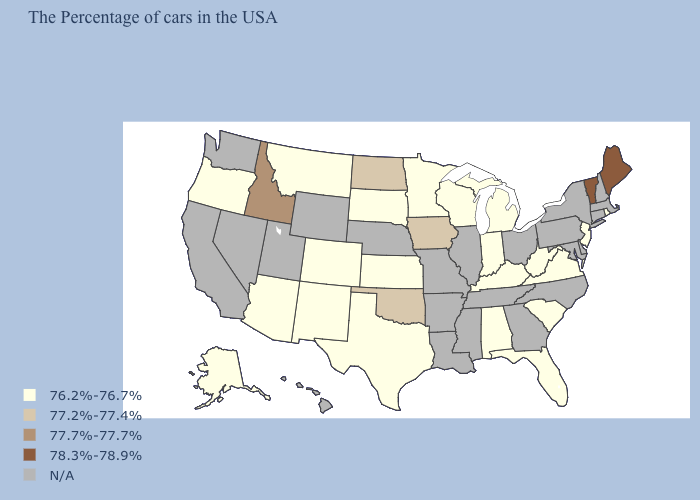Does the map have missing data?
Concise answer only. Yes. Among the states that border Arkansas , which have the highest value?
Short answer required. Oklahoma. What is the lowest value in the USA?
Answer briefly. 76.2%-76.7%. Is the legend a continuous bar?
Give a very brief answer. No. Does the first symbol in the legend represent the smallest category?
Keep it brief. Yes. What is the value of New York?
Write a very short answer. N/A. Which states have the lowest value in the West?
Be succinct. Colorado, New Mexico, Montana, Arizona, Oregon, Alaska. Name the states that have a value in the range 77.2%-77.4%?
Keep it brief. Iowa, Oklahoma, North Dakota. What is the value of Indiana?
Be succinct. 76.2%-76.7%. Does the first symbol in the legend represent the smallest category?
Keep it brief. Yes. What is the highest value in states that border Missouri?
Quick response, please. 77.2%-77.4%. Does Iowa have the highest value in the USA?
Keep it brief. No. What is the highest value in states that border Massachusetts?
Write a very short answer. 78.3%-78.9%. Which states have the lowest value in the USA?
Short answer required. Rhode Island, New Jersey, Virginia, South Carolina, West Virginia, Florida, Michigan, Kentucky, Indiana, Alabama, Wisconsin, Minnesota, Kansas, Texas, South Dakota, Colorado, New Mexico, Montana, Arizona, Oregon, Alaska. Which states hav the highest value in the West?
Keep it brief. Idaho. 